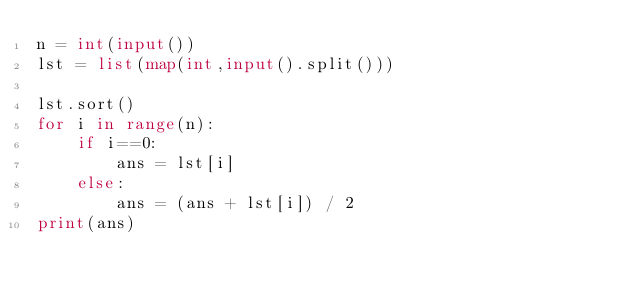Convert code to text. <code><loc_0><loc_0><loc_500><loc_500><_Python_>n = int(input())
lst = list(map(int,input().split()))

lst.sort()
for i in range(n):
    if i==0:
        ans = lst[i]
    else:
        ans = (ans + lst[i]) / 2
print(ans)</code> 